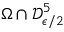<formula> <loc_0><loc_0><loc_500><loc_500>\Omega \cap \mathcal { D } _ { \epsilon / 2 } ^ { 5 }</formula> 